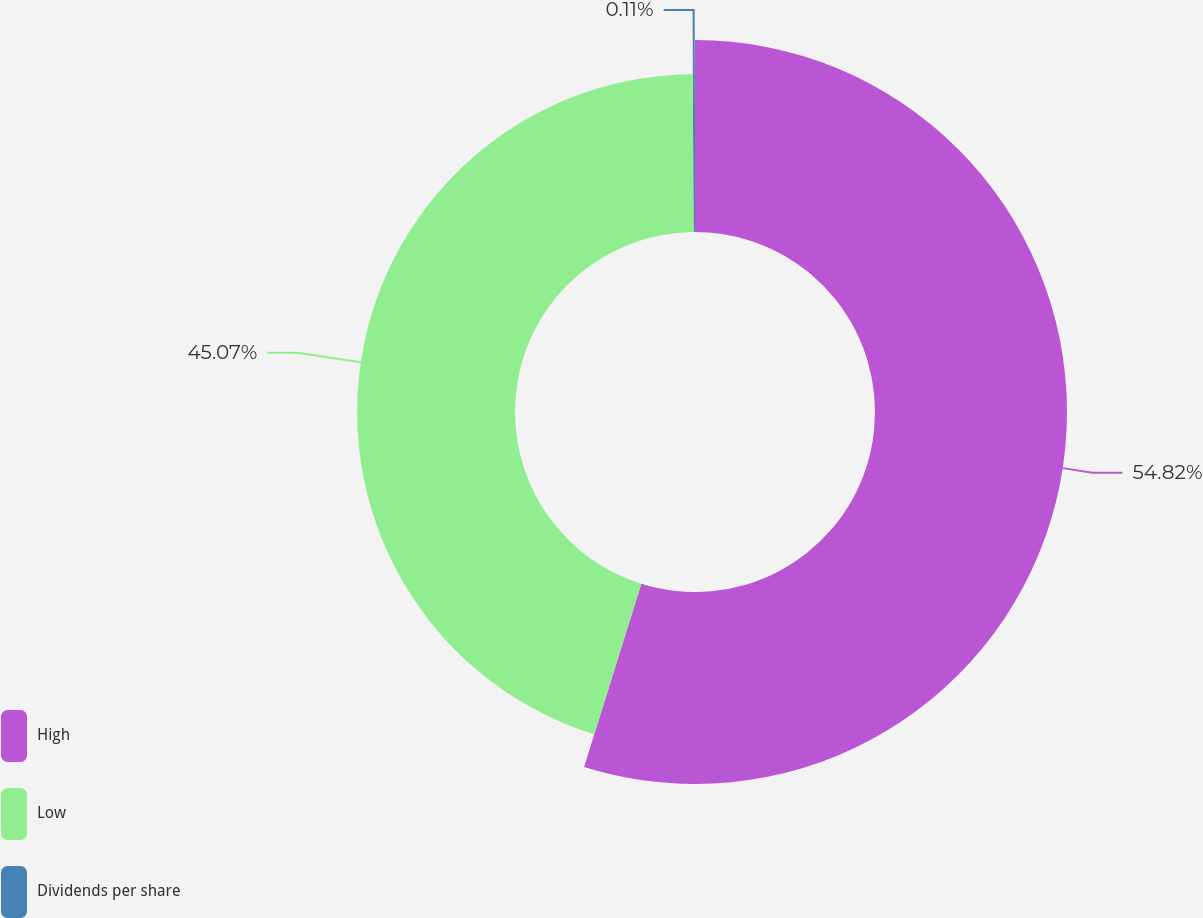<chart> <loc_0><loc_0><loc_500><loc_500><pie_chart><fcel>High<fcel>Low<fcel>Dividends per share<nl><fcel>54.82%<fcel>45.07%<fcel>0.11%<nl></chart> 